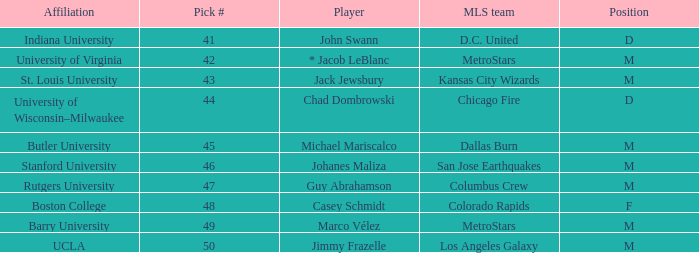What is the position of the Colorado Rapids team? F. 